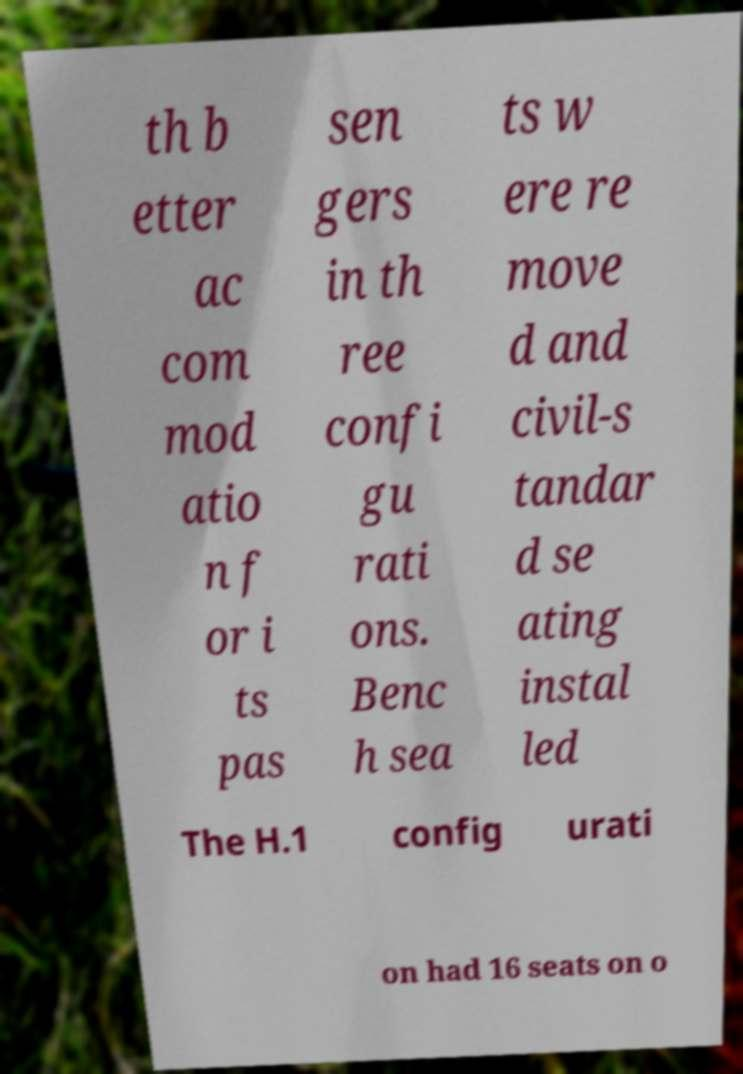Please read and relay the text visible in this image. What does it say? th b etter ac com mod atio n f or i ts pas sen gers in th ree confi gu rati ons. Benc h sea ts w ere re move d and civil-s tandar d se ating instal led The H.1 config urati on had 16 seats on o 